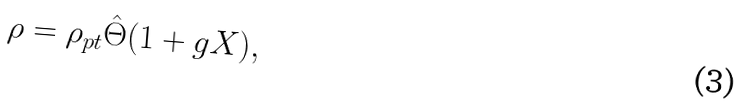Convert formula to latex. <formula><loc_0><loc_0><loc_500><loc_500>\rho = \rho _ { p t } \hat { \Theta } ( 1 + g X ) ,</formula> 